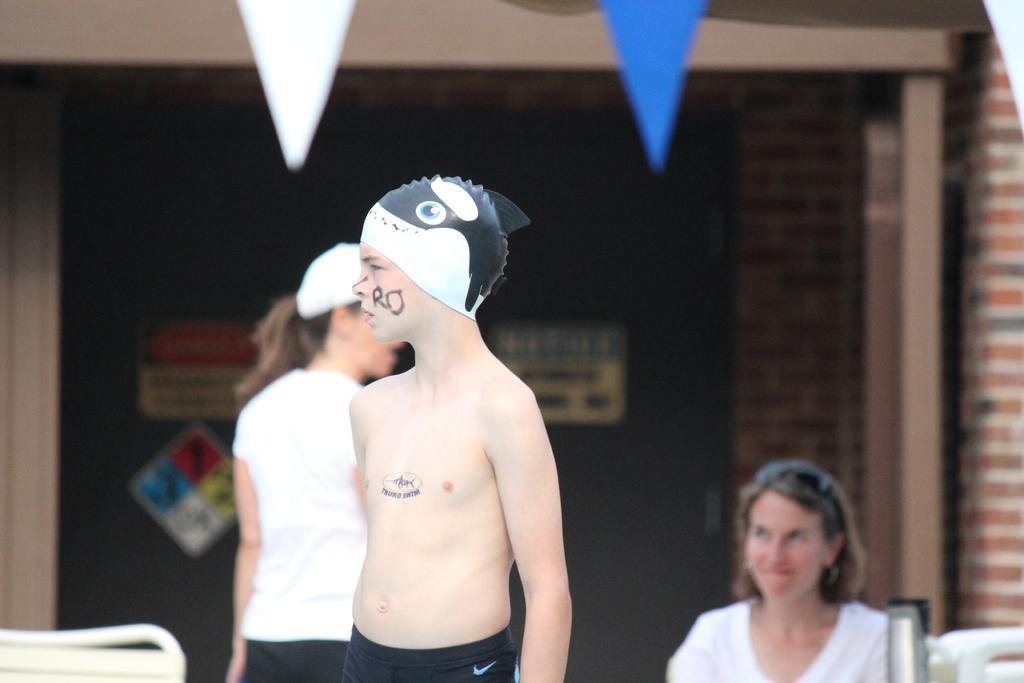Can you describe this image briefly? There is a boy wearing a cap. In the back there are two people. Also there is a wall with some posters. 